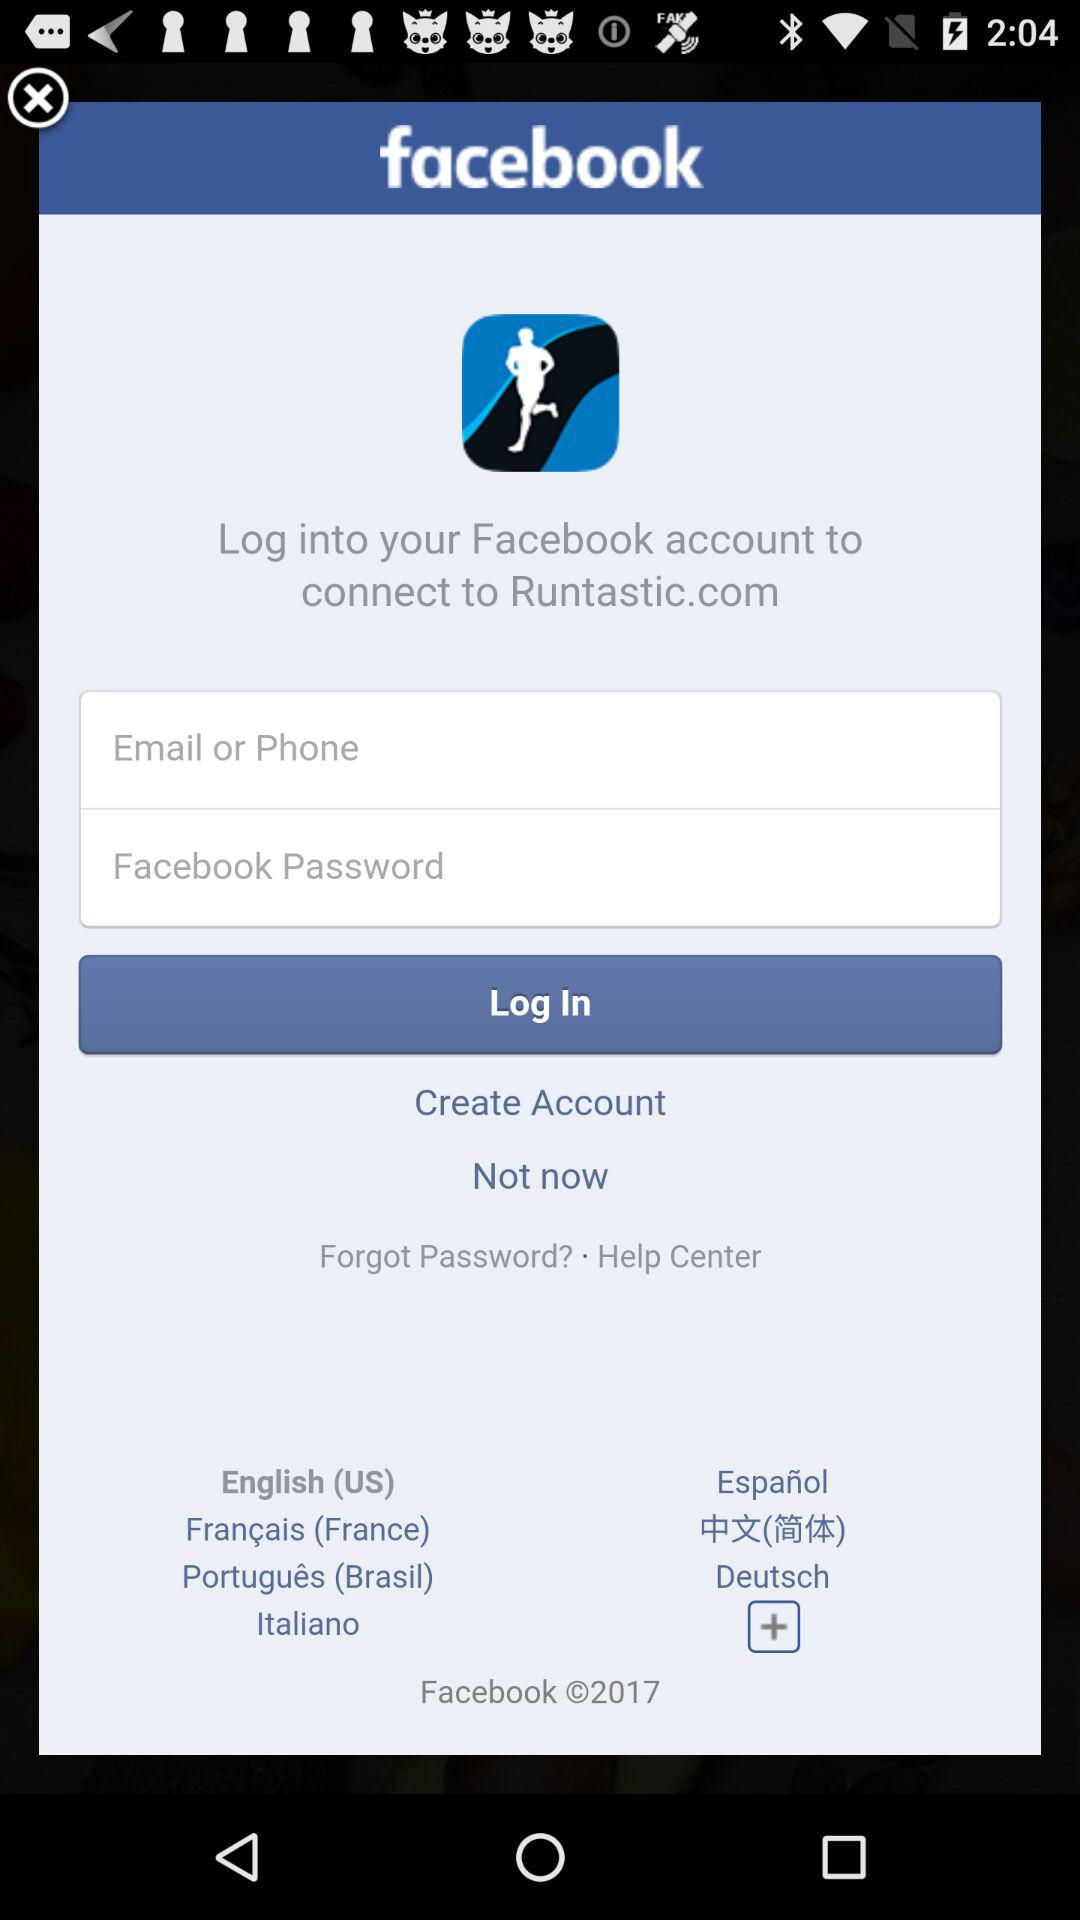What is the application name? The application names are "Runtastic.com" and "facebook". 